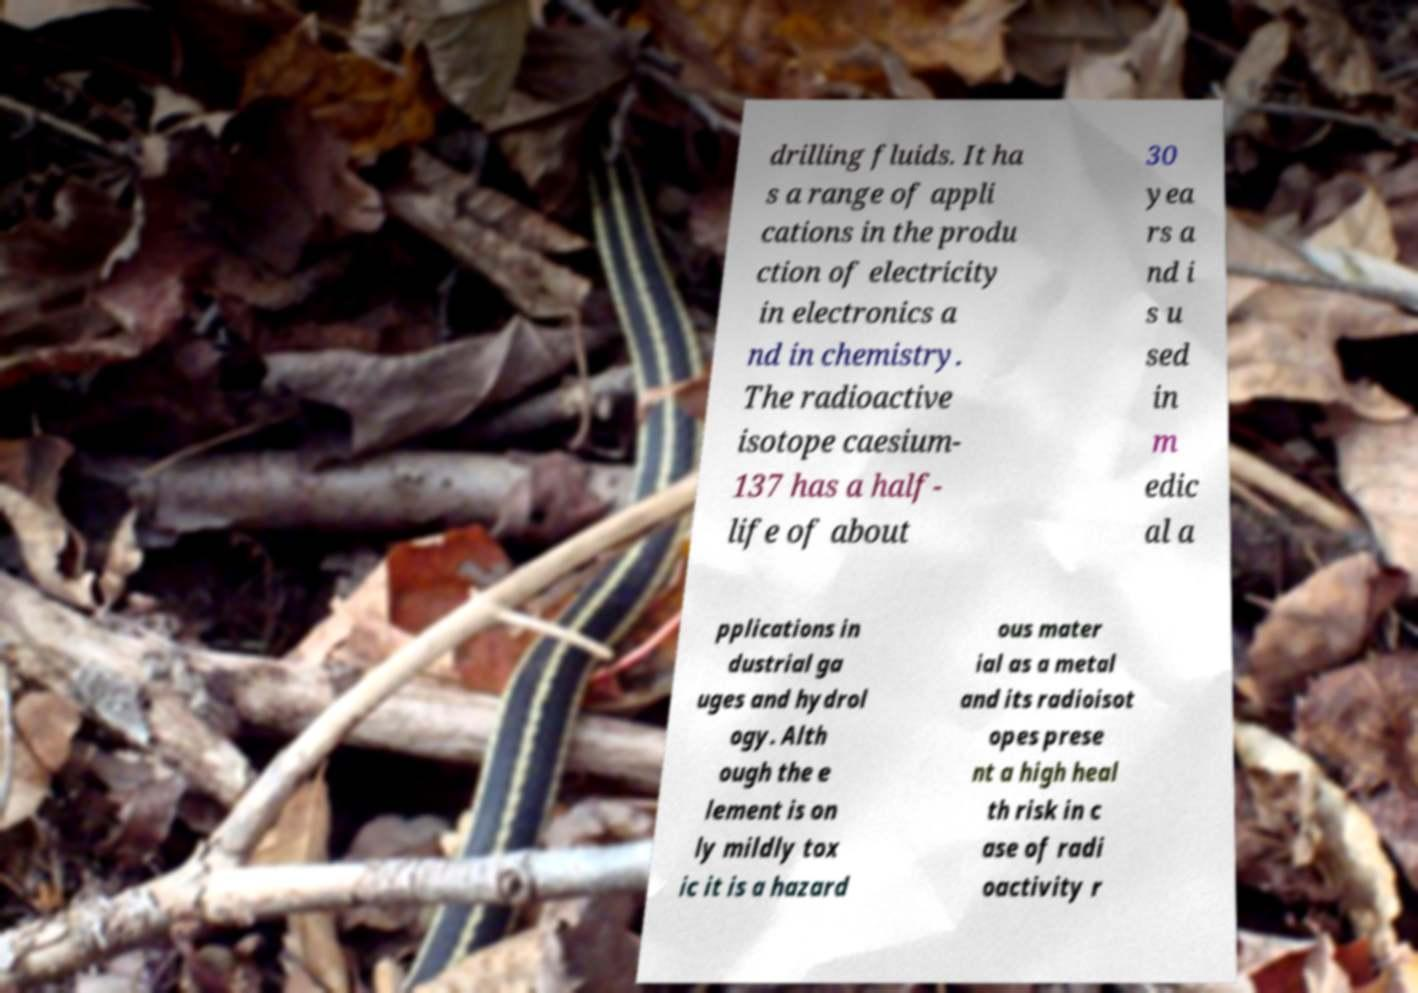For documentation purposes, I need the text within this image transcribed. Could you provide that? drilling fluids. It ha s a range of appli cations in the produ ction of electricity in electronics a nd in chemistry. The radioactive isotope caesium- 137 has a half- life of about 30 yea rs a nd i s u sed in m edic al a pplications in dustrial ga uges and hydrol ogy. Alth ough the e lement is on ly mildly tox ic it is a hazard ous mater ial as a metal and its radioisot opes prese nt a high heal th risk in c ase of radi oactivity r 